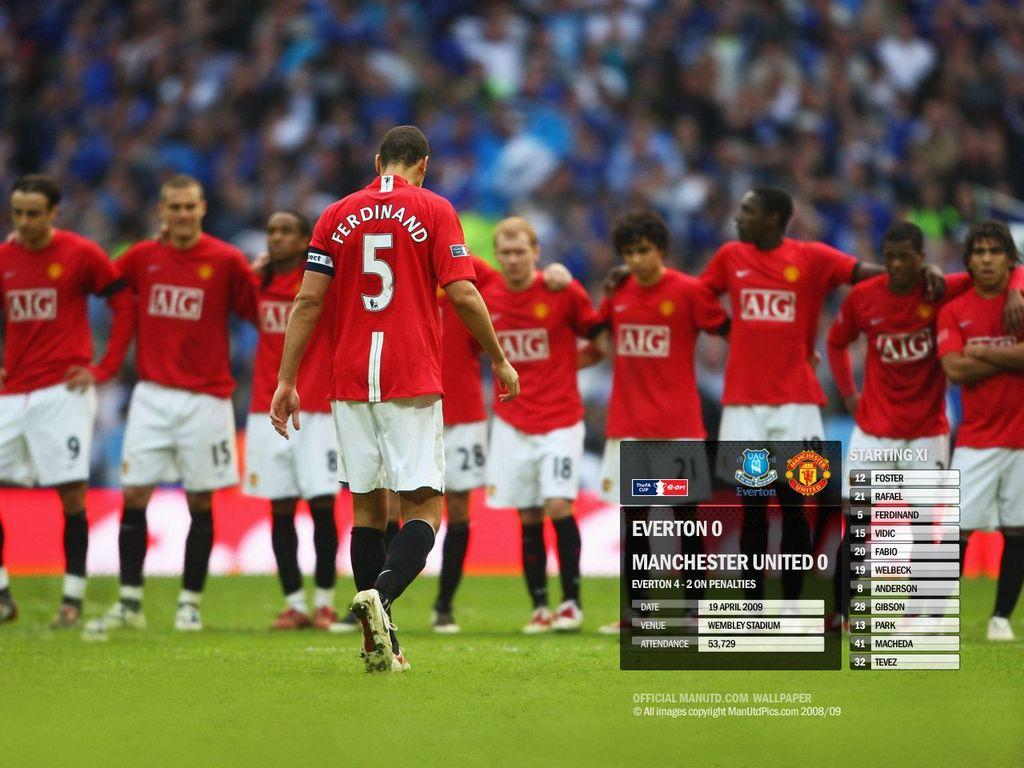<image>
Relay a brief, clear account of the picture shown. soccer players from the AIG team line up on a field 